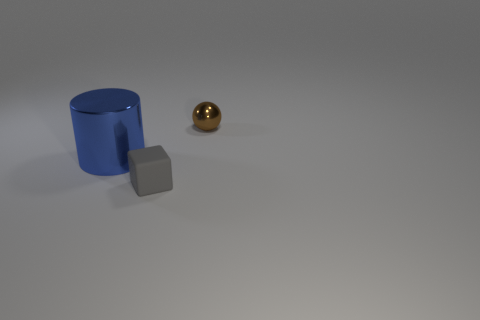Add 1 large cylinders. How many objects exist? 4 Subtract all balls. How many objects are left? 2 Subtract all tiny purple metal balls. Subtract all matte things. How many objects are left? 2 Add 3 tiny brown things. How many tiny brown things are left? 4 Add 1 small gray blocks. How many small gray blocks exist? 2 Subtract 0 blue cubes. How many objects are left? 3 